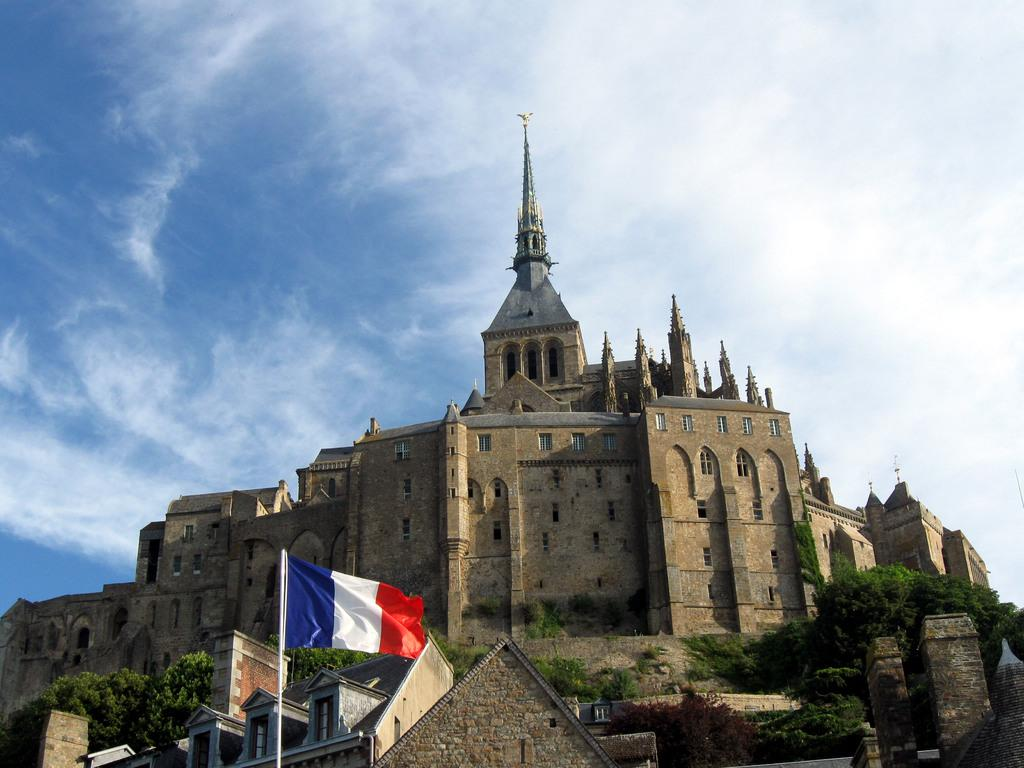What is the main structure in the middle of the image? There is a castle in the middle of the image. What is located at the bottom of the image? There is a flag at the bottom of the image. What is visible at the top of the image? The sky is visible at the top of the image. What type of vegetation surrounds the castle? There are trees on either side of the castle. Can you see the lip of the island in the image? There is no island present in the image, so there is no lip to be seen. 